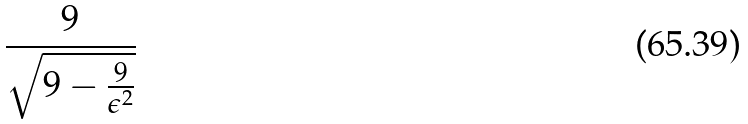Convert formula to latex. <formula><loc_0><loc_0><loc_500><loc_500>\frac { 9 } { \sqrt { 9 - \frac { 9 } { \epsilon ^ { 2 } } } }</formula> 